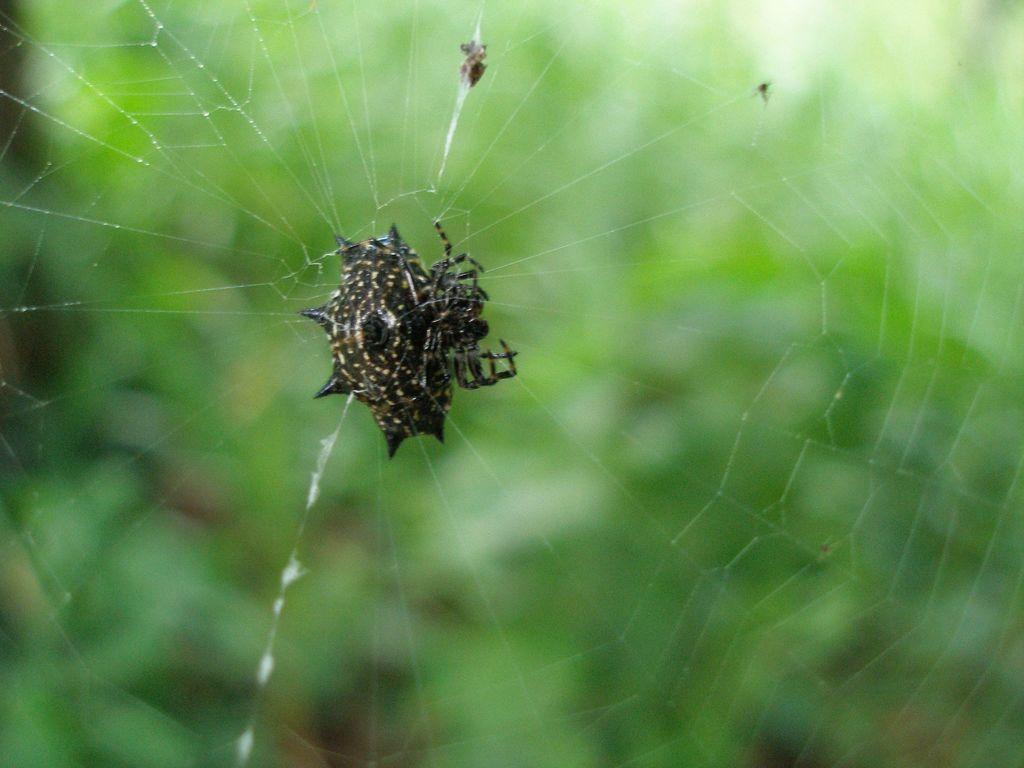Describe this image in one or two sentences. In this image in the center there is an insect and the background is blurry. 